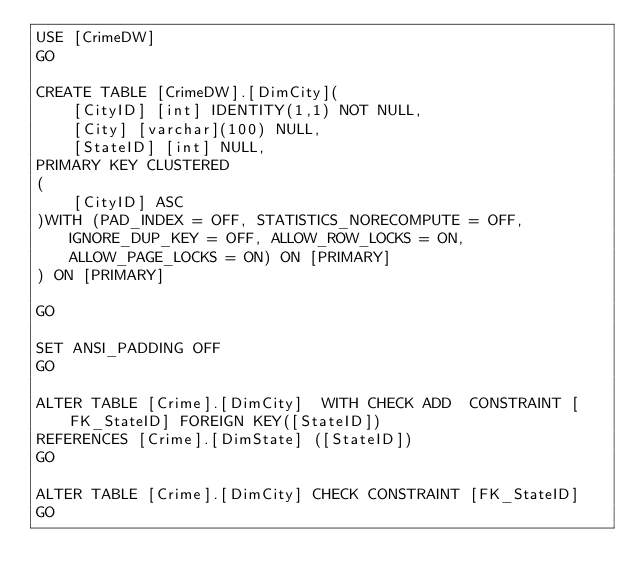<code> <loc_0><loc_0><loc_500><loc_500><_SQL_>USE [CrimeDW]
GO

CREATE TABLE [CrimeDW].[DimCity](
	[CityID] [int] IDENTITY(1,1) NOT NULL,
	[City] [varchar](100) NULL,
	[StateID] [int] NULL,
PRIMARY KEY CLUSTERED 
(
	[CityID] ASC
)WITH (PAD_INDEX = OFF, STATISTICS_NORECOMPUTE = OFF, IGNORE_DUP_KEY = OFF, ALLOW_ROW_LOCKS = ON, ALLOW_PAGE_LOCKS = ON) ON [PRIMARY]
) ON [PRIMARY]

GO

SET ANSI_PADDING OFF
GO

ALTER TABLE [Crime].[DimCity]  WITH CHECK ADD  CONSTRAINT [FK_StateID] FOREIGN KEY([StateID])
REFERENCES [Crime].[DimState] ([StateID])
GO

ALTER TABLE [Crime].[DimCity] CHECK CONSTRAINT [FK_StateID]
GO


</code> 